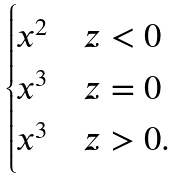Convert formula to latex. <formula><loc_0><loc_0><loc_500><loc_500>\begin{cases} x ^ { 2 } & z < 0 \\ x ^ { 3 } & z = 0 \\ x ^ { 3 } & z > 0 . \end{cases}</formula> 